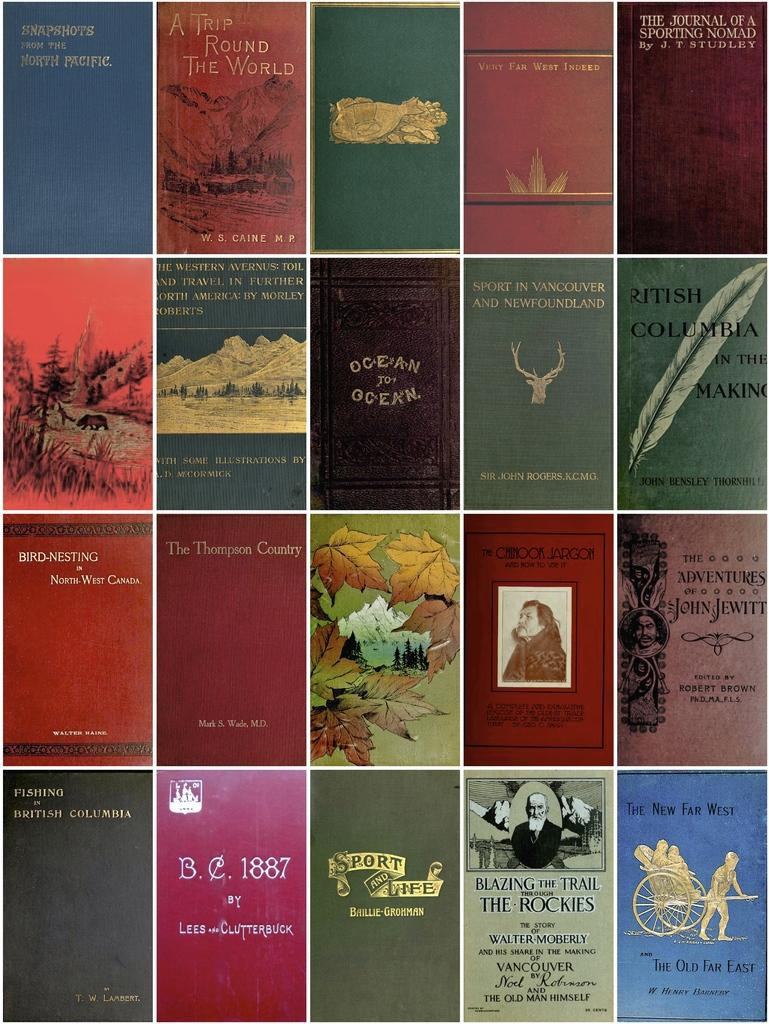<image>
Render a clear and concise summary of the photo. A group of twenty different books by various authors. 